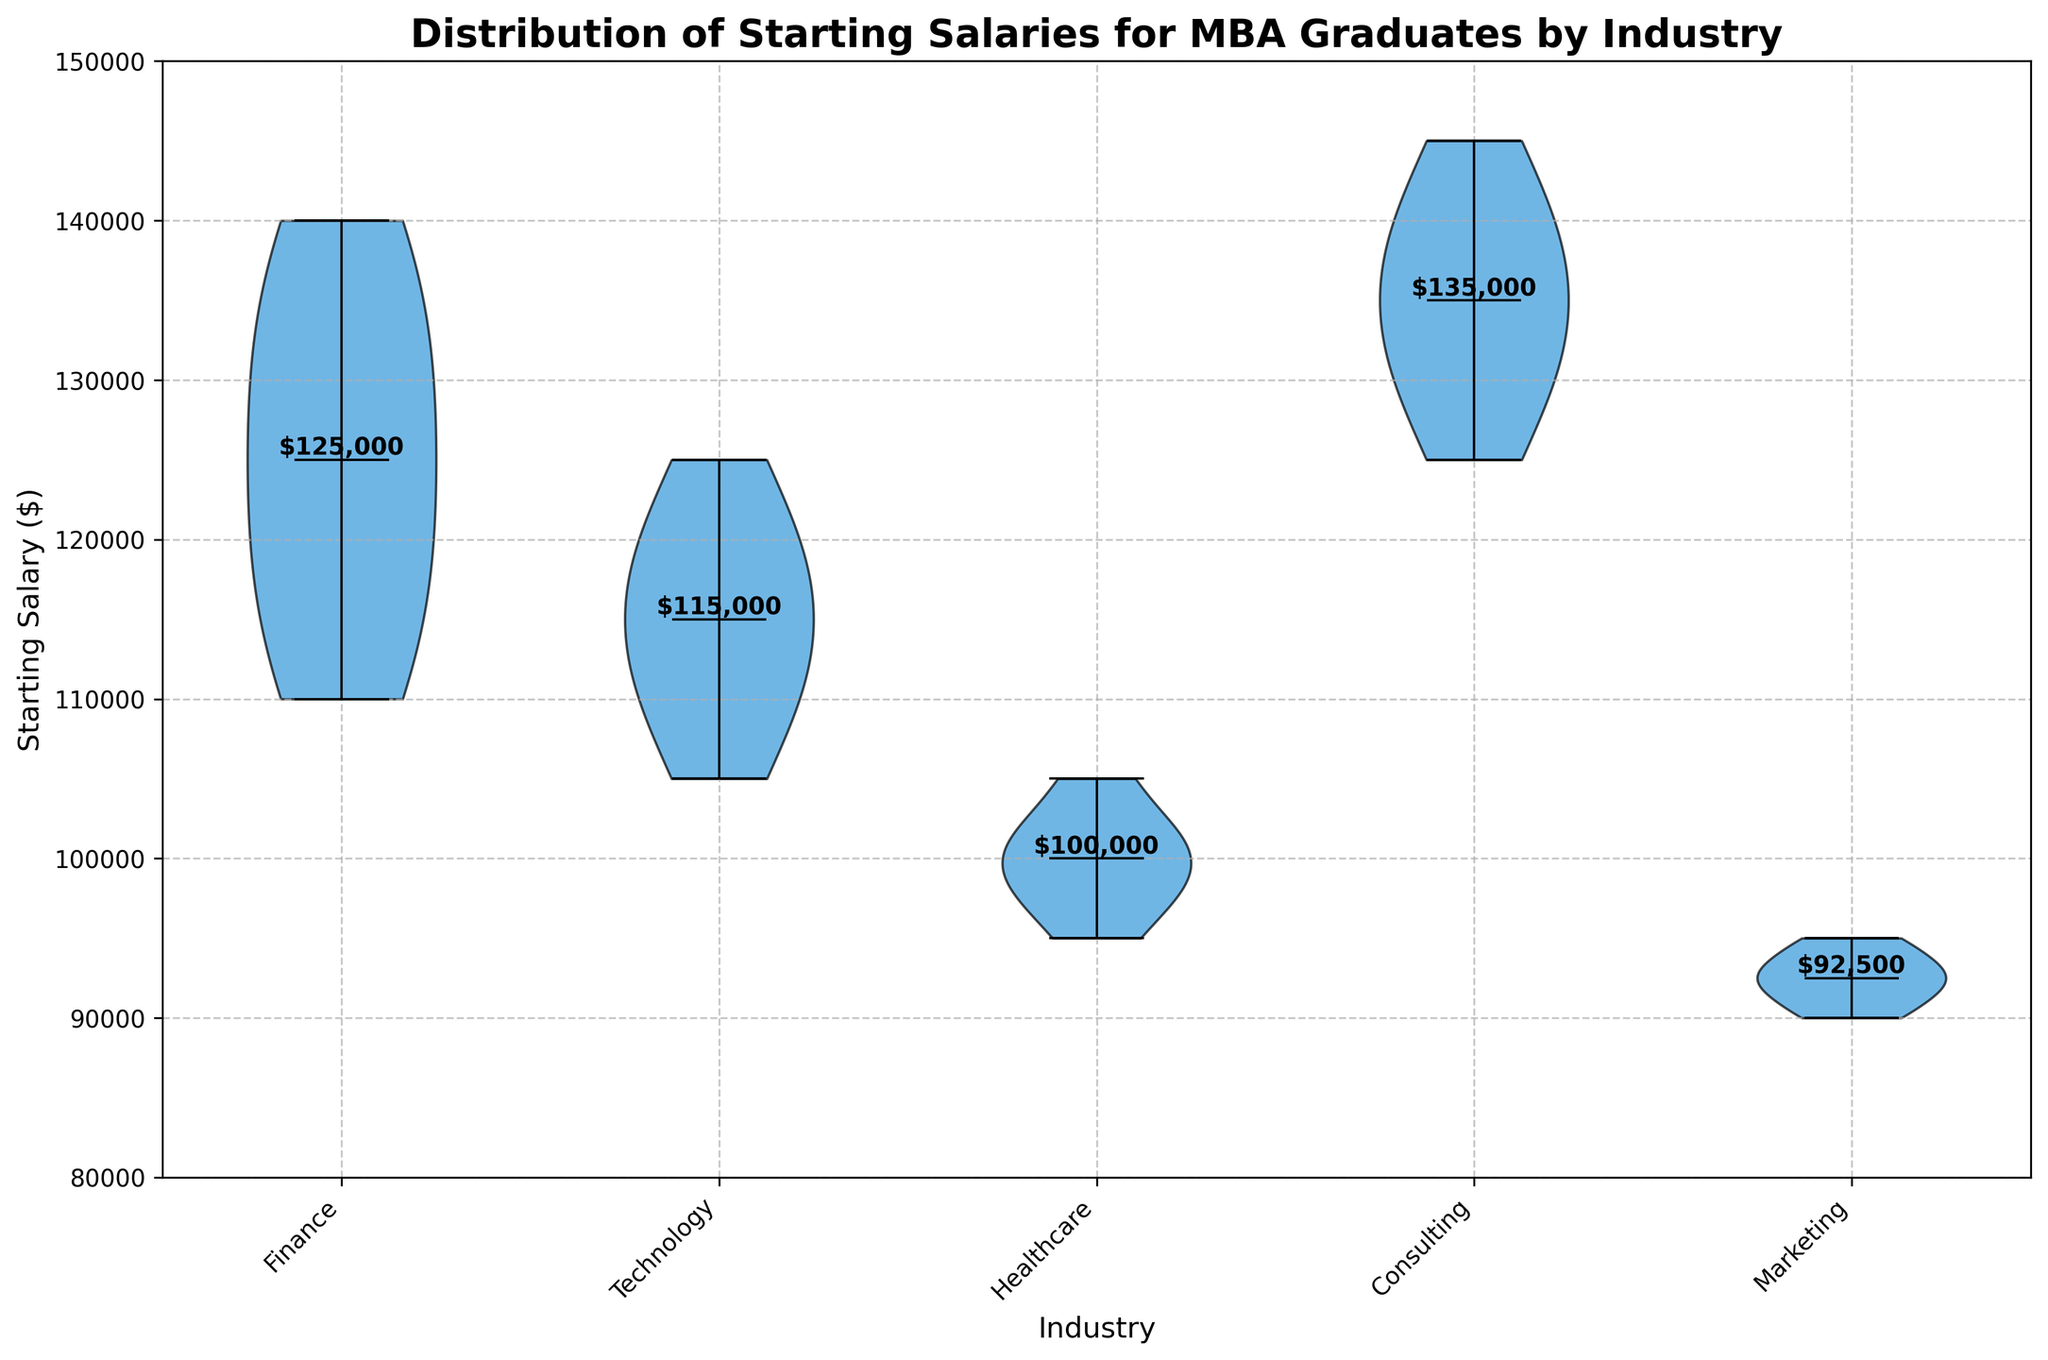What's the title of the figure? The title of the figure is located at the top of the plot and reads "Distribution of Starting Salaries for MBA Graduates by Industry".
Answer: Distribution of Starting Salaries for MBA Graduates by Industry What is the salary range shown on the y-axis? The y-axis, which represents the starting salary, ranges from 80,000 to 150,000 dollars.
Answer: 80,000 to 150,000 dollars Which industry has the highest median starting salary? By examining the position of the median lines on each violin plot, Consulting has the highest median starting salary.
Answer: Consulting Are there any industries with overlapping salary distributions? Yes, the salary distributions for Finance and Technology overlap, as can be seen in the violin plots where the shapes interleave in their range.
Answer: Finance and Technology Which industry has the narrowest distribution range for starting salaries? The narrowest distribution can be identified by the width of the violin plot. Marketing has the narrowest distribution as its violin plot is the slimmest.
Answer: Marketing What is the median starting salary for the Healthcare industry? The median starting salary is indicated by the horizontal line inside the Healthcare violin plot. The value is $100,000.
Answer: $100,000 How does the median starting salary in Technology compare to that in Finance? The median starting salary is found by locating the median lines in each plot. The median for Technology is $115,000, while for Finance it is $125,000. The median salary in Finance is higher than in Technology.
Answer: Finance is higher Which industry shows the most variability in starting salaries? The industry with the most variability can be observed by the violin plot with the widest spread. Finance shows the most variability.
Answer: Finance How do the salaries in Healthcare compare to those in Marketing? By examining the height and spread of the violin plots, Healthcare salaries are generally higher and have a wider distribution compared to Marketing.
Answer: Healthcare salaries are higher 